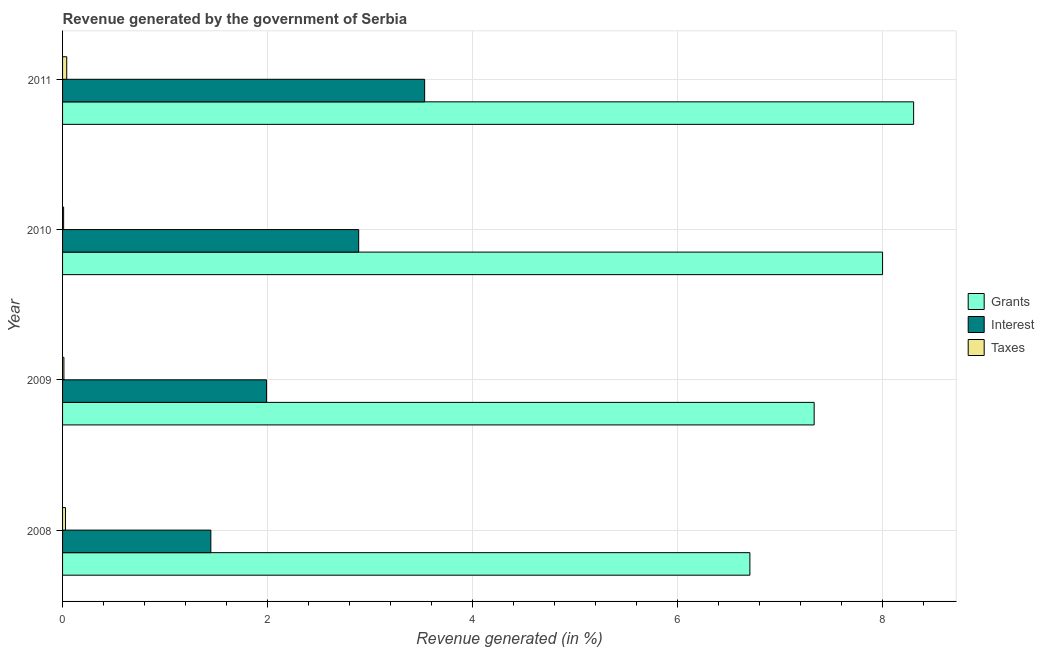How many different coloured bars are there?
Offer a very short reply. 3. How many groups of bars are there?
Provide a succinct answer. 4. Are the number of bars per tick equal to the number of legend labels?
Keep it short and to the point. Yes. Are the number of bars on each tick of the Y-axis equal?
Provide a short and direct response. Yes. How many bars are there on the 2nd tick from the top?
Offer a terse response. 3. How many bars are there on the 2nd tick from the bottom?
Give a very brief answer. 3. In how many cases, is the number of bars for a given year not equal to the number of legend labels?
Provide a short and direct response. 0. What is the percentage of revenue generated by interest in 2008?
Your answer should be very brief. 1.45. Across all years, what is the maximum percentage of revenue generated by taxes?
Ensure brevity in your answer.  0.04. Across all years, what is the minimum percentage of revenue generated by taxes?
Ensure brevity in your answer.  0.01. What is the total percentage of revenue generated by interest in the graph?
Keep it short and to the point. 9.86. What is the difference between the percentage of revenue generated by taxes in 2008 and that in 2010?
Offer a terse response. 0.02. What is the difference between the percentage of revenue generated by grants in 2010 and the percentage of revenue generated by interest in 2011?
Make the answer very short. 4.47. What is the average percentage of revenue generated by grants per year?
Provide a succinct answer. 7.59. In the year 2011, what is the difference between the percentage of revenue generated by interest and percentage of revenue generated by taxes?
Your answer should be very brief. 3.49. What is the ratio of the percentage of revenue generated by interest in 2008 to that in 2011?
Offer a very short reply. 0.41. Is the difference between the percentage of revenue generated by interest in 2009 and 2011 greater than the difference between the percentage of revenue generated by taxes in 2009 and 2011?
Make the answer very short. No. What is the difference between the highest and the second highest percentage of revenue generated by grants?
Provide a short and direct response. 0.3. What is the difference between the highest and the lowest percentage of revenue generated by taxes?
Your response must be concise. 0.03. In how many years, is the percentage of revenue generated by interest greater than the average percentage of revenue generated by interest taken over all years?
Your answer should be very brief. 2. Is the sum of the percentage of revenue generated by taxes in 2008 and 2009 greater than the maximum percentage of revenue generated by interest across all years?
Provide a succinct answer. No. What does the 2nd bar from the top in 2009 represents?
Ensure brevity in your answer.  Interest. What does the 1st bar from the bottom in 2008 represents?
Your response must be concise. Grants. Are all the bars in the graph horizontal?
Give a very brief answer. Yes. Are the values on the major ticks of X-axis written in scientific E-notation?
Your answer should be very brief. No. Where does the legend appear in the graph?
Make the answer very short. Center right. How many legend labels are there?
Provide a short and direct response. 3. What is the title of the graph?
Offer a very short reply. Revenue generated by the government of Serbia. What is the label or title of the X-axis?
Your response must be concise. Revenue generated (in %). What is the Revenue generated (in %) of Grants in 2008?
Your response must be concise. 6.71. What is the Revenue generated (in %) in Interest in 2008?
Ensure brevity in your answer.  1.45. What is the Revenue generated (in %) in Taxes in 2008?
Keep it short and to the point. 0.03. What is the Revenue generated (in %) of Grants in 2009?
Provide a short and direct response. 7.33. What is the Revenue generated (in %) in Interest in 2009?
Offer a terse response. 1.99. What is the Revenue generated (in %) of Taxes in 2009?
Make the answer very short. 0.01. What is the Revenue generated (in %) in Grants in 2010?
Your answer should be very brief. 8. What is the Revenue generated (in %) in Interest in 2010?
Offer a terse response. 2.89. What is the Revenue generated (in %) of Taxes in 2010?
Your response must be concise. 0.01. What is the Revenue generated (in %) of Grants in 2011?
Make the answer very short. 8.3. What is the Revenue generated (in %) in Interest in 2011?
Provide a short and direct response. 3.53. What is the Revenue generated (in %) in Taxes in 2011?
Make the answer very short. 0.04. Across all years, what is the maximum Revenue generated (in %) of Grants?
Give a very brief answer. 8.3. Across all years, what is the maximum Revenue generated (in %) of Interest?
Ensure brevity in your answer.  3.53. Across all years, what is the maximum Revenue generated (in %) of Taxes?
Ensure brevity in your answer.  0.04. Across all years, what is the minimum Revenue generated (in %) in Grants?
Make the answer very short. 6.71. Across all years, what is the minimum Revenue generated (in %) in Interest?
Offer a very short reply. 1.45. Across all years, what is the minimum Revenue generated (in %) of Taxes?
Make the answer very short. 0.01. What is the total Revenue generated (in %) of Grants in the graph?
Ensure brevity in your answer.  30.35. What is the total Revenue generated (in %) in Interest in the graph?
Provide a succinct answer. 9.86. What is the total Revenue generated (in %) of Taxes in the graph?
Offer a very short reply. 0.09. What is the difference between the Revenue generated (in %) in Grants in 2008 and that in 2009?
Offer a very short reply. -0.63. What is the difference between the Revenue generated (in %) in Interest in 2008 and that in 2009?
Make the answer very short. -0.54. What is the difference between the Revenue generated (in %) of Taxes in 2008 and that in 2009?
Your answer should be compact. 0.02. What is the difference between the Revenue generated (in %) in Grants in 2008 and that in 2010?
Keep it short and to the point. -1.29. What is the difference between the Revenue generated (in %) of Interest in 2008 and that in 2010?
Your answer should be very brief. -1.44. What is the difference between the Revenue generated (in %) of Taxes in 2008 and that in 2010?
Offer a terse response. 0.02. What is the difference between the Revenue generated (in %) in Grants in 2008 and that in 2011?
Make the answer very short. -1.6. What is the difference between the Revenue generated (in %) in Interest in 2008 and that in 2011?
Your answer should be very brief. -2.09. What is the difference between the Revenue generated (in %) in Taxes in 2008 and that in 2011?
Make the answer very short. -0.01. What is the difference between the Revenue generated (in %) in Grants in 2009 and that in 2010?
Make the answer very short. -0.67. What is the difference between the Revenue generated (in %) in Interest in 2009 and that in 2010?
Offer a terse response. -0.9. What is the difference between the Revenue generated (in %) of Taxes in 2009 and that in 2010?
Provide a short and direct response. 0. What is the difference between the Revenue generated (in %) of Grants in 2009 and that in 2011?
Your answer should be compact. -0.97. What is the difference between the Revenue generated (in %) in Interest in 2009 and that in 2011?
Keep it short and to the point. -1.54. What is the difference between the Revenue generated (in %) of Taxes in 2009 and that in 2011?
Offer a terse response. -0.03. What is the difference between the Revenue generated (in %) of Grants in 2010 and that in 2011?
Offer a very short reply. -0.3. What is the difference between the Revenue generated (in %) of Interest in 2010 and that in 2011?
Provide a succinct answer. -0.64. What is the difference between the Revenue generated (in %) in Taxes in 2010 and that in 2011?
Make the answer very short. -0.03. What is the difference between the Revenue generated (in %) in Grants in 2008 and the Revenue generated (in %) in Interest in 2009?
Provide a short and direct response. 4.72. What is the difference between the Revenue generated (in %) of Grants in 2008 and the Revenue generated (in %) of Taxes in 2009?
Give a very brief answer. 6.69. What is the difference between the Revenue generated (in %) in Interest in 2008 and the Revenue generated (in %) in Taxes in 2009?
Provide a short and direct response. 1.43. What is the difference between the Revenue generated (in %) in Grants in 2008 and the Revenue generated (in %) in Interest in 2010?
Keep it short and to the point. 3.82. What is the difference between the Revenue generated (in %) of Grants in 2008 and the Revenue generated (in %) of Taxes in 2010?
Offer a terse response. 6.7. What is the difference between the Revenue generated (in %) of Interest in 2008 and the Revenue generated (in %) of Taxes in 2010?
Your answer should be very brief. 1.44. What is the difference between the Revenue generated (in %) in Grants in 2008 and the Revenue generated (in %) in Interest in 2011?
Make the answer very short. 3.17. What is the difference between the Revenue generated (in %) of Grants in 2008 and the Revenue generated (in %) of Taxes in 2011?
Give a very brief answer. 6.67. What is the difference between the Revenue generated (in %) of Interest in 2008 and the Revenue generated (in %) of Taxes in 2011?
Provide a short and direct response. 1.41. What is the difference between the Revenue generated (in %) of Grants in 2009 and the Revenue generated (in %) of Interest in 2010?
Ensure brevity in your answer.  4.44. What is the difference between the Revenue generated (in %) of Grants in 2009 and the Revenue generated (in %) of Taxes in 2010?
Provide a short and direct response. 7.32. What is the difference between the Revenue generated (in %) in Interest in 2009 and the Revenue generated (in %) in Taxes in 2010?
Offer a very short reply. 1.98. What is the difference between the Revenue generated (in %) of Grants in 2009 and the Revenue generated (in %) of Interest in 2011?
Provide a short and direct response. 3.8. What is the difference between the Revenue generated (in %) of Grants in 2009 and the Revenue generated (in %) of Taxes in 2011?
Give a very brief answer. 7.29. What is the difference between the Revenue generated (in %) of Interest in 2009 and the Revenue generated (in %) of Taxes in 2011?
Your answer should be very brief. 1.95. What is the difference between the Revenue generated (in %) of Grants in 2010 and the Revenue generated (in %) of Interest in 2011?
Give a very brief answer. 4.47. What is the difference between the Revenue generated (in %) in Grants in 2010 and the Revenue generated (in %) in Taxes in 2011?
Your answer should be compact. 7.96. What is the difference between the Revenue generated (in %) in Interest in 2010 and the Revenue generated (in %) in Taxes in 2011?
Your response must be concise. 2.85. What is the average Revenue generated (in %) of Grants per year?
Provide a succinct answer. 7.59. What is the average Revenue generated (in %) in Interest per year?
Provide a succinct answer. 2.47. What is the average Revenue generated (in %) of Taxes per year?
Provide a short and direct response. 0.02. In the year 2008, what is the difference between the Revenue generated (in %) in Grants and Revenue generated (in %) in Interest?
Give a very brief answer. 5.26. In the year 2008, what is the difference between the Revenue generated (in %) in Grants and Revenue generated (in %) in Taxes?
Offer a terse response. 6.68. In the year 2008, what is the difference between the Revenue generated (in %) of Interest and Revenue generated (in %) of Taxes?
Ensure brevity in your answer.  1.42. In the year 2009, what is the difference between the Revenue generated (in %) of Grants and Revenue generated (in %) of Interest?
Offer a very short reply. 5.34. In the year 2009, what is the difference between the Revenue generated (in %) of Grants and Revenue generated (in %) of Taxes?
Make the answer very short. 7.32. In the year 2009, what is the difference between the Revenue generated (in %) in Interest and Revenue generated (in %) in Taxes?
Offer a very short reply. 1.98. In the year 2010, what is the difference between the Revenue generated (in %) of Grants and Revenue generated (in %) of Interest?
Offer a terse response. 5.11. In the year 2010, what is the difference between the Revenue generated (in %) of Grants and Revenue generated (in %) of Taxes?
Your answer should be very brief. 7.99. In the year 2010, what is the difference between the Revenue generated (in %) of Interest and Revenue generated (in %) of Taxes?
Keep it short and to the point. 2.88. In the year 2011, what is the difference between the Revenue generated (in %) in Grants and Revenue generated (in %) in Interest?
Keep it short and to the point. 4.77. In the year 2011, what is the difference between the Revenue generated (in %) in Grants and Revenue generated (in %) in Taxes?
Give a very brief answer. 8.26. In the year 2011, what is the difference between the Revenue generated (in %) in Interest and Revenue generated (in %) in Taxes?
Keep it short and to the point. 3.49. What is the ratio of the Revenue generated (in %) of Grants in 2008 to that in 2009?
Make the answer very short. 0.91. What is the ratio of the Revenue generated (in %) in Interest in 2008 to that in 2009?
Keep it short and to the point. 0.73. What is the ratio of the Revenue generated (in %) of Taxes in 2008 to that in 2009?
Ensure brevity in your answer.  2.18. What is the ratio of the Revenue generated (in %) in Grants in 2008 to that in 2010?
Offer a very short reply. 0.84. What is the ratio of the Revenue generated (in %) of Interest in 2008 to that in 2010?
Keep it short and to the point. 0.5. What is the ratio of the Revenue generated (in %) in Taxes in 2008 to that in 2010?
Offer a very short reply. 2.74. What is the ratio of the Revenue generated (in %) in Grants in 2008 to that in 2011?
Offer a very short reply. 0.81. What is the ratio of the Revenue generated (in %) in Interest in 2008 to that in 2011?
Offer a very short reply. 0.41. What is the ratio of the Revenue generated (in %) in Taxes in 2008 to that in 2011?
Give a very brief answer. 0.7. What is the ratio of the Revenue generated (in %) in Grants in 2009 to that in 2010?
Your response must be concise. 0.92. What is the ratio of the Revenue generated (in %) in Interest in 2009 to that in 2010?
Your answer should be very brief. 0.69. What is the ratio of the Revenue generated (in %) of Taxes in 2009 to that in 2010?
Your answer should be compact. 1.25. What is the ratio of the Revenue generated (in %) in Grants in 2009 to that in 2011?
Provide a short and direct response. 0.88. What is the ratio of the Revenue generated (in %) in Interest in 2009 to that in 2011?
Offer a terse response. 0.56. What is the ratio of the Revenue generated (in %) of Taxes in 2009 to that in 2011?
Your response must be concise. 0.32. What is the ratio of the Revenue generated (in %) in Grants in 2010 to that in 2011?
Your answer should be very brief. 0.96. What is the ratio of the Revenue generated (in %) in Interest in 2010 to that in 2011?
Keep it short and to the point. 0.82. What is the ratio of the Revenue generated (in %) of Taxes in 2010 to that in 2011?
Give a very brief answer. 0.26. What is the difference between the highest and the second highest Revenue generated (in %) in Grants?
Ensure brevity in your answer.  0.3. What is the difference between the highest and the second highest Revenue generated (in %) in Interest?
Your answer should be compact. 0.64. What is the difference between the highest and the second highest Revenue generated (in %) of Taxes?
Provide a short and direct response. 0.01. What is the difference between the highest and the lowest Revenue generated (in %) in Grants?
Ensure brevity in your answer.  1.6. What is the difference between the highest and the lowest Revenue generated (in %) of Interest?
Give a very brief answer. 2.09. What is the difference between the highest and the lowest Revenue generated (in %) in Taxes?
Provide a short and direct response. 0.03. 